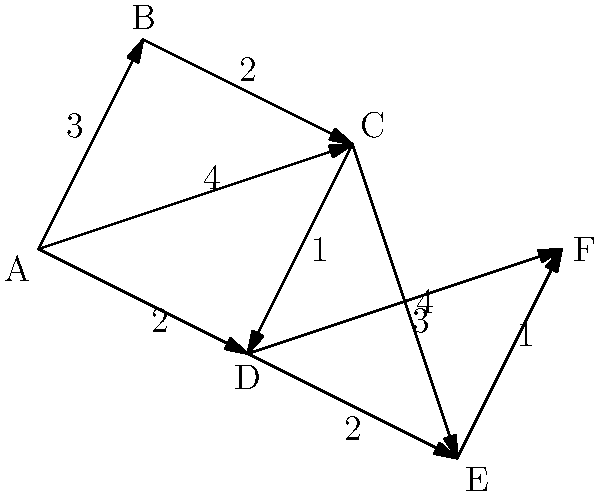Given the road network connecting residential areas (A) to alternative job sites (F), what is the shortest path from A to F, and what is its total distance? To find the shortest path from A to F, we'll use Dijkstra's algorithm:

1. Initialize:
   - Distance to A: 0
   - Distance to all other nodes: infinity
   - Previous node for all nodes: undefined

2. Visit A:
   - Update distances: B(3), C(4), D(2)
   - Mark A as visited

3. Visit D (closest unvisited node):
   - Update distances: E(4), F(6)
   - Mark D as visited

4. Visit B:
   - Update distance to C: min(4, 3+2) = 4
   - Mark B as visited

5. Visit C:
   - Update distances: E(min(4, 4+3)=4), D(min(2, 4+1)=2)
   - Mark C as visited

6. Visit E:
   - Update distance to F: min(6, 4+1) = 5
   - Mark E as visited

7. Visit F:
   - No updates needed
   - Mark F as visited

The shortest path is A -> D -> E -> F with a total distance of 5.
Answer: A -> D -> E -> F, distance: 5 